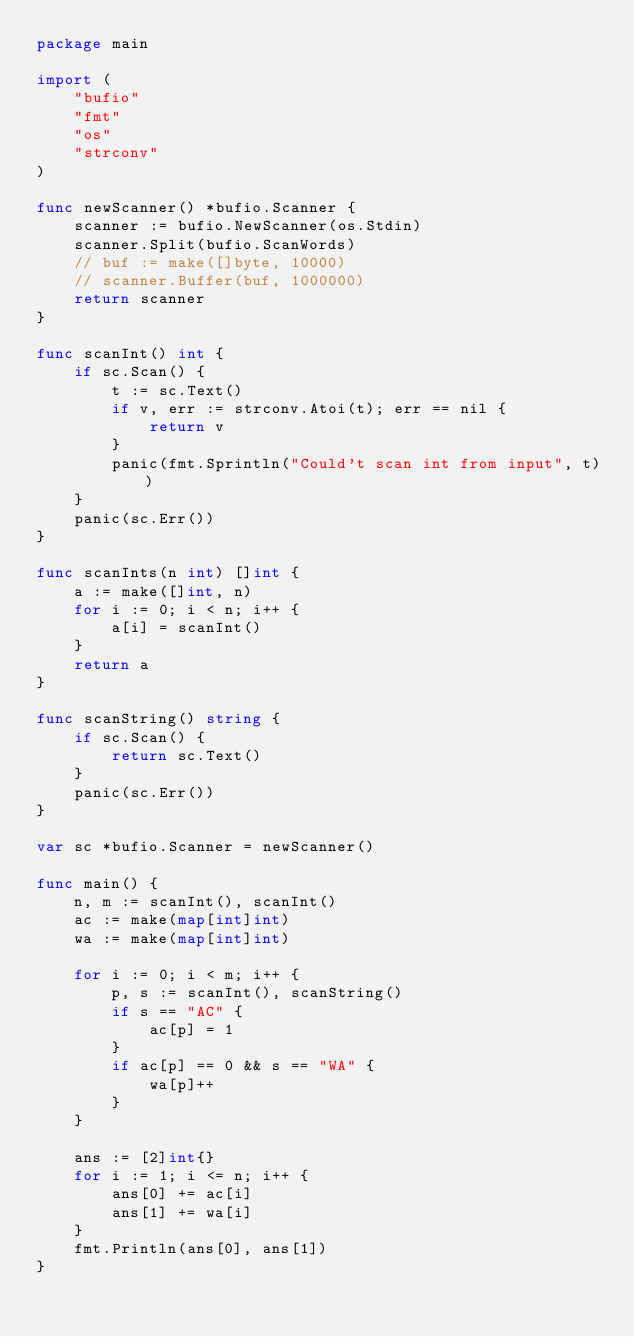<code> <loc_0><loc_0><loc_500><loc_500><_Go_>package main

import (
	"bufio"
	"fmt"
	"os"
	"strconv"
)

func newScanner() *bufio.Scanner {
	scanner := bufio.NewScanner(os.Stdin)
	scanner.Split(bufio.ScanWords)
	// buf := make([]byte, 10000)
	// scanner.Buffer(buf, 1000000)
	return scanner
}

func scanInt() int {
	if sc.Scan() {
		t := sc.Text()
		if v, err := strconv.Atoi(t); err == nil {
			return v
		}
		panic(fmt.Sprintln("Could't scan int from input", t))
	}
	panic(sc.Err())
}

func scanInts(n int) []int {
	a := make([]int, n)
	for i := 0; i < n; i++ {
		a[i] = scanInt()
	}
	return a
}

func scanString() string {
	if sc.Scan() {
		return sc.Text()
	}
	panic(sc.Err())
}

var sc *bufio.Scanner = newScanner()

func main() {
	n, m := scanInt(), scanInt()
	ac := make(map[int]int)
	wa := make(map[int]int)

	for i := 0; i < m; i++ {
		p, s := scanInt(), scanString()
		if s == "AC" {
			ac[p] = 1
		}
		if ac[p] == 0 && s == "WA" {
			wa[p]++
		}
	}

	ans := [2]int{}
	for i := 1; i <= n; i++ {
		ans[0] += ac[i]
		ans[1] += wa[i]
	}
	fmt.Println(ans[0], ans[1])
}
</code> 